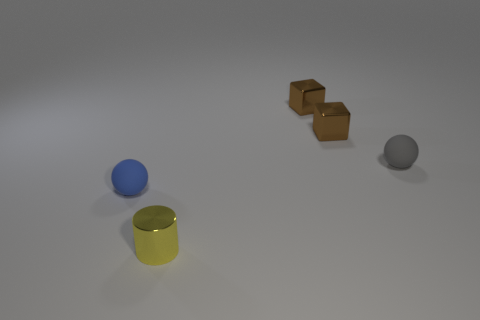Subtract all spheres. How many objects are left? 3 Add 5 tiny blue rubber spheres. How many objects exist? 10 Add 5 cubes. How many cubes are left? 7 Add 4 small cyan rubber balls. How many small cyan rubber balls exist? 4 Subtract 0 green spheres. How many objects are left? 5 Subtract all gray rubber balls. Subtract all small blue matte balls. How many objects are left? 3 